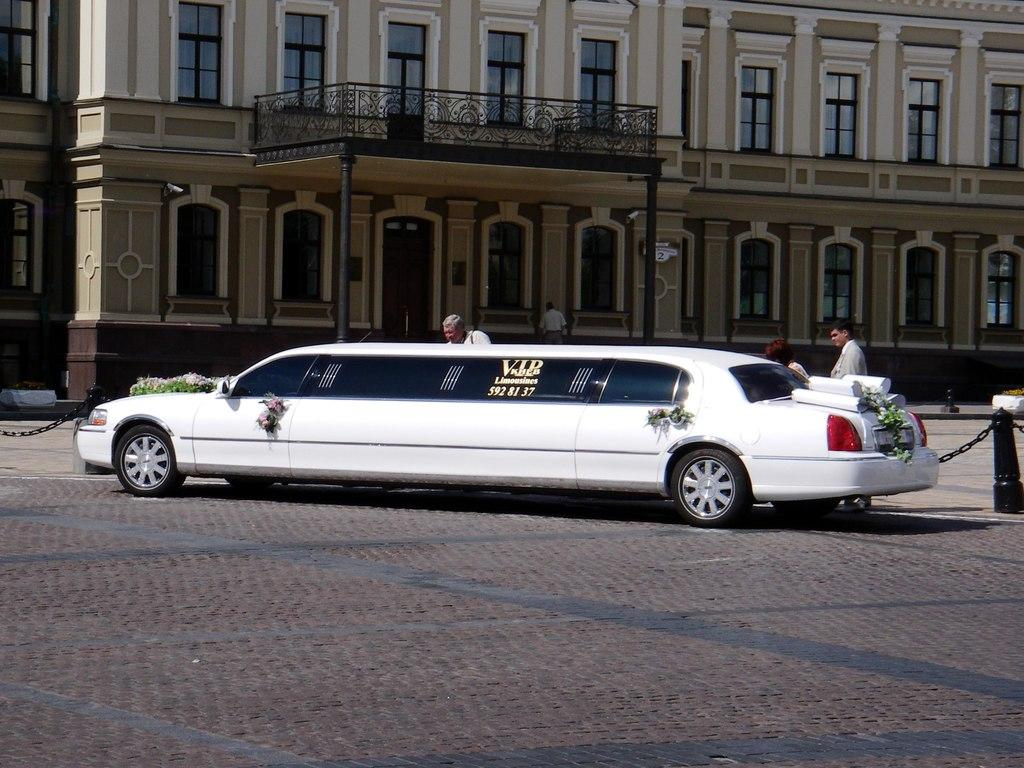What is the main subject of the image? There is a car in the image. Can you describe the people in the image? There are people in the image, and they are in the middle of the image. What can be seen in the background of the image? There is a building in the background of the image. What is the purpose of the chains on either side of the image? The chains on either side of the image are not described in the facts, so we cannot determine their purpose. Can you tell me how many goldfish are swimming in the pan in the image? There are no goldfish or pans present in the image. 